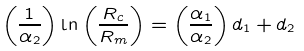Convert formula to latex. <formula><loc_0><loc_0><loc_500><loc_500>\left ( \frac { 1 } { \alpha _ { 2 } } \right ) \ln \left ( \frac { R _ { c } } { R _ { m } } \right ) = \left ( \frac { \alpha _ { 1 } } { \alpha _ { 2 } } \right ) d _ { 1 } + d _ { 2 }</formula> 